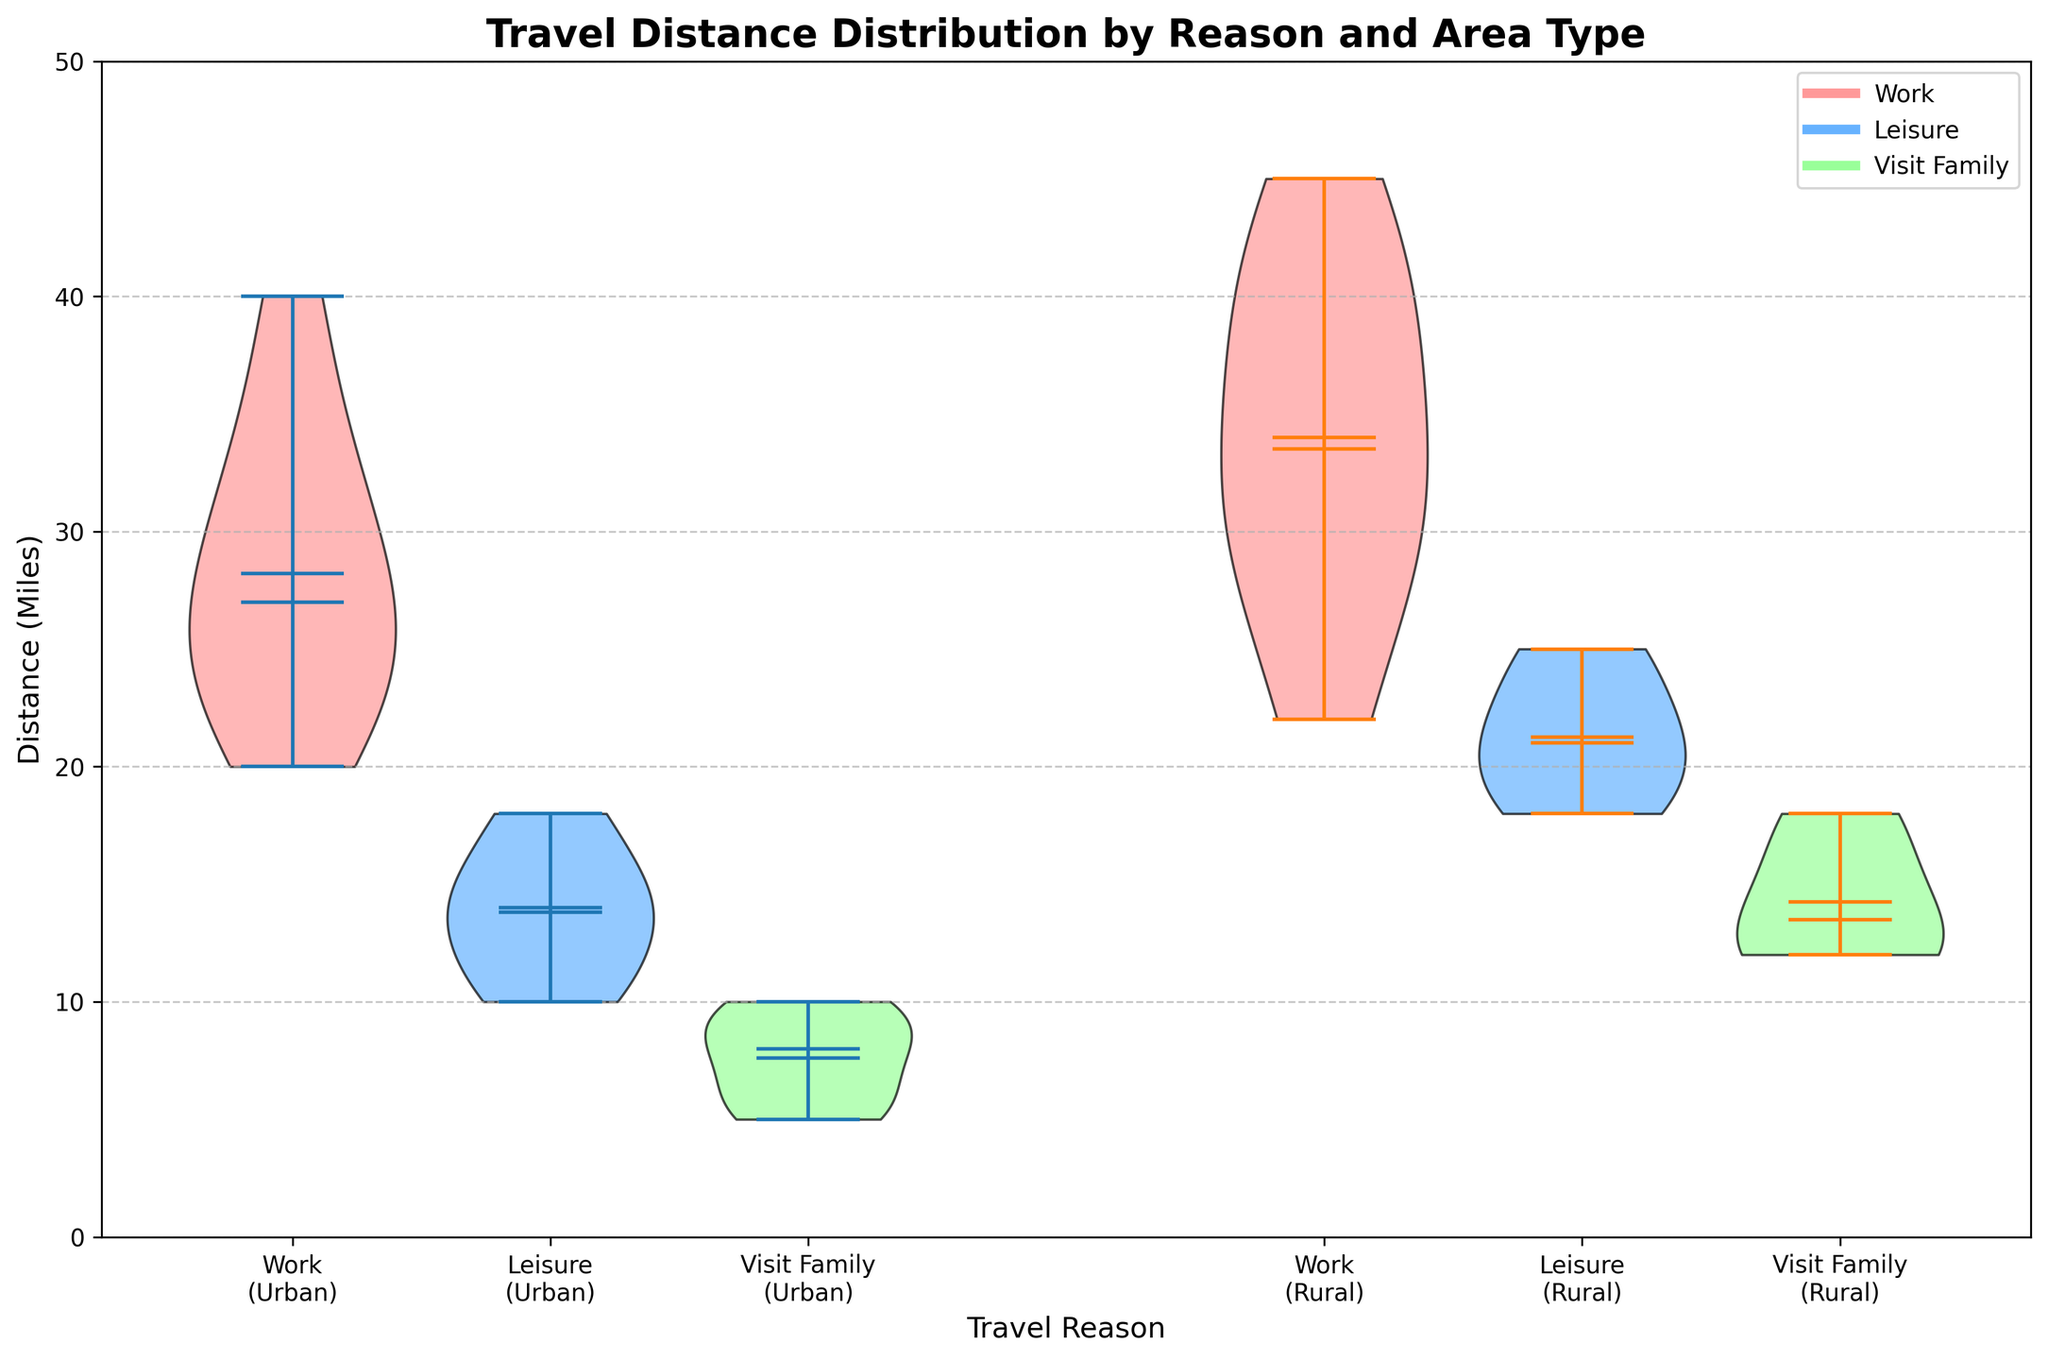What's the title of the figure? The title is at the top of the figure and is often the first thing that catches the viewer's attention to understand what the plot represents.
Answer: Travel Distance Distribution by Reason and Area Type What are the x-axis labels? The x-axis labels are located at the bottom of the figure, specifying the categories being compared in the chart.
Answer: Work (Urban), Leisure (Urban), Visit Family (Urban), Work (Rural), Leisure (Rural), Visit Family (Rural) Which color represents the "Work" travel reason? The legend in the top right corner of the figure indicates which color corresponds to each travel reason by showing a colored line with a label next to it.
Answer: A shade of red In which type of area (urban or rural) do people travel the longest distance for work on average? Compare the position and width of the violins for "Work" in both urban and rural areas along the y-axis, focusing on the location of the mean line within the violin plots.
Answer: Rural Which travel reason has the highest median travel distance in urban areas? Look for the horizontal line within the violin plots for different travel reasons under the urban category and check which one is highest on the y-axis.
Answer: Work What's the median travel distance for 'Leisure' in rural areas? Identify the position of the horizontal line within the 'Leisure' violin plot in the rural area section and read the corresponding y-axis value.
Answer: Approximately 20 miles How does the range of travel distances for 'Visit Family' compare between urban and rural areas? Compare the full height of the 'Visit Family' violin plots in both urban and rural sections to see the spread from the lowest to the highest point.
Answer: Rural areas show a wider range What is the range of travel distances for "Work" in urban areas? Examine the top and bottom extremes of the 'Work' violin plot in the urban section to read the minimum and maximum points along the y-axis.
Answer: Approximately 22 to 40 miles Are there overlapping ranges for travel distances between any two categories in rural areas? Observe the top and bottom extremes of the violin plots in rural areas to identify any span overlaps along the y-axis.
Answer: Yes, between "Leisure" and "Visit Family" Do urban or rural areas show more variability in travel distances overall? Compare the overall span (the width and spread of violin plots) within urban and rural sections to determine which has more noticeable variation across all travel reasons.
Answer: Rural 